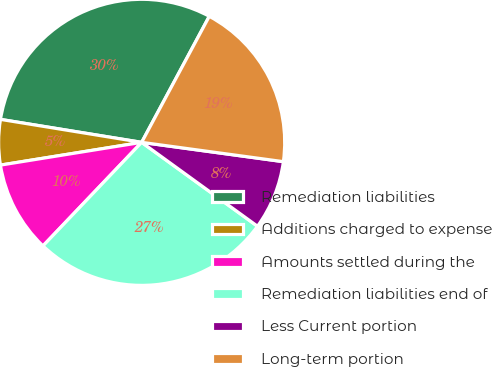<chart> <loc_0><loc_0><loc_500><loc_500><pie_chart><fcel>Remediation liabilities<fcel>Additions charged to expense<fcel>Amounts settled during the<fcel>Remediation liabilities end of<fcel>Less Current portion<fcel>Long-term portion<nl><fcel>30.27%<fcel>5.11%<fcel>10.34%<fcel>27.14%<fcel>7.82%<fcel>19.32%<nl></chart> 